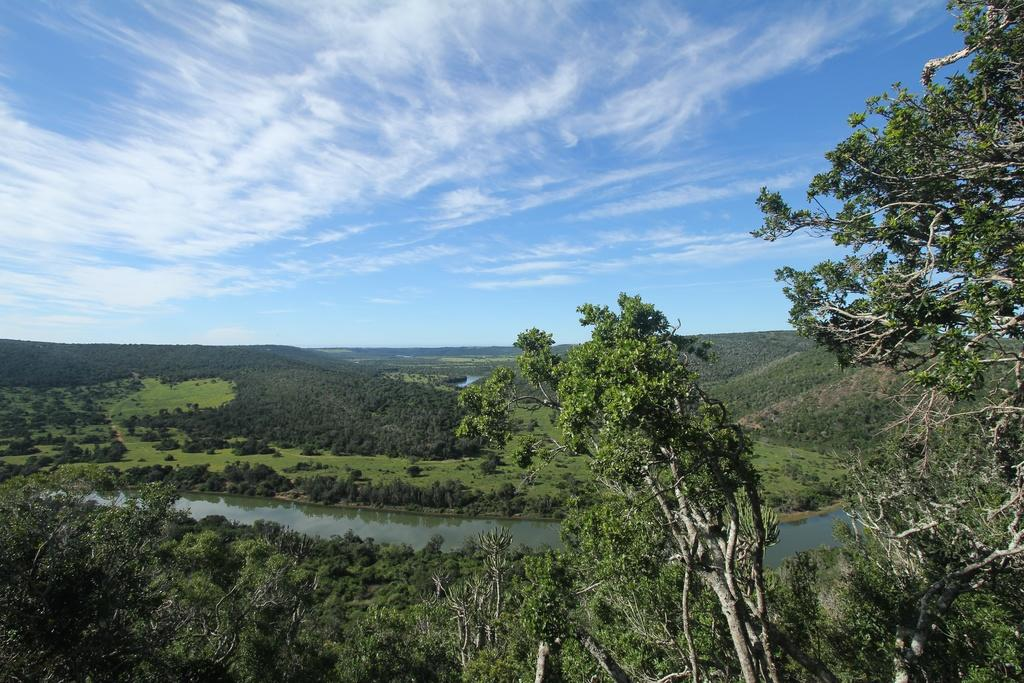What type of natural feature is in the image? There is a river in the image. What can be seen around the river? Trees, grass, and plants are present around the river. How many apples are being smashed by friends in the image? There are no apples or friends present in the image. 